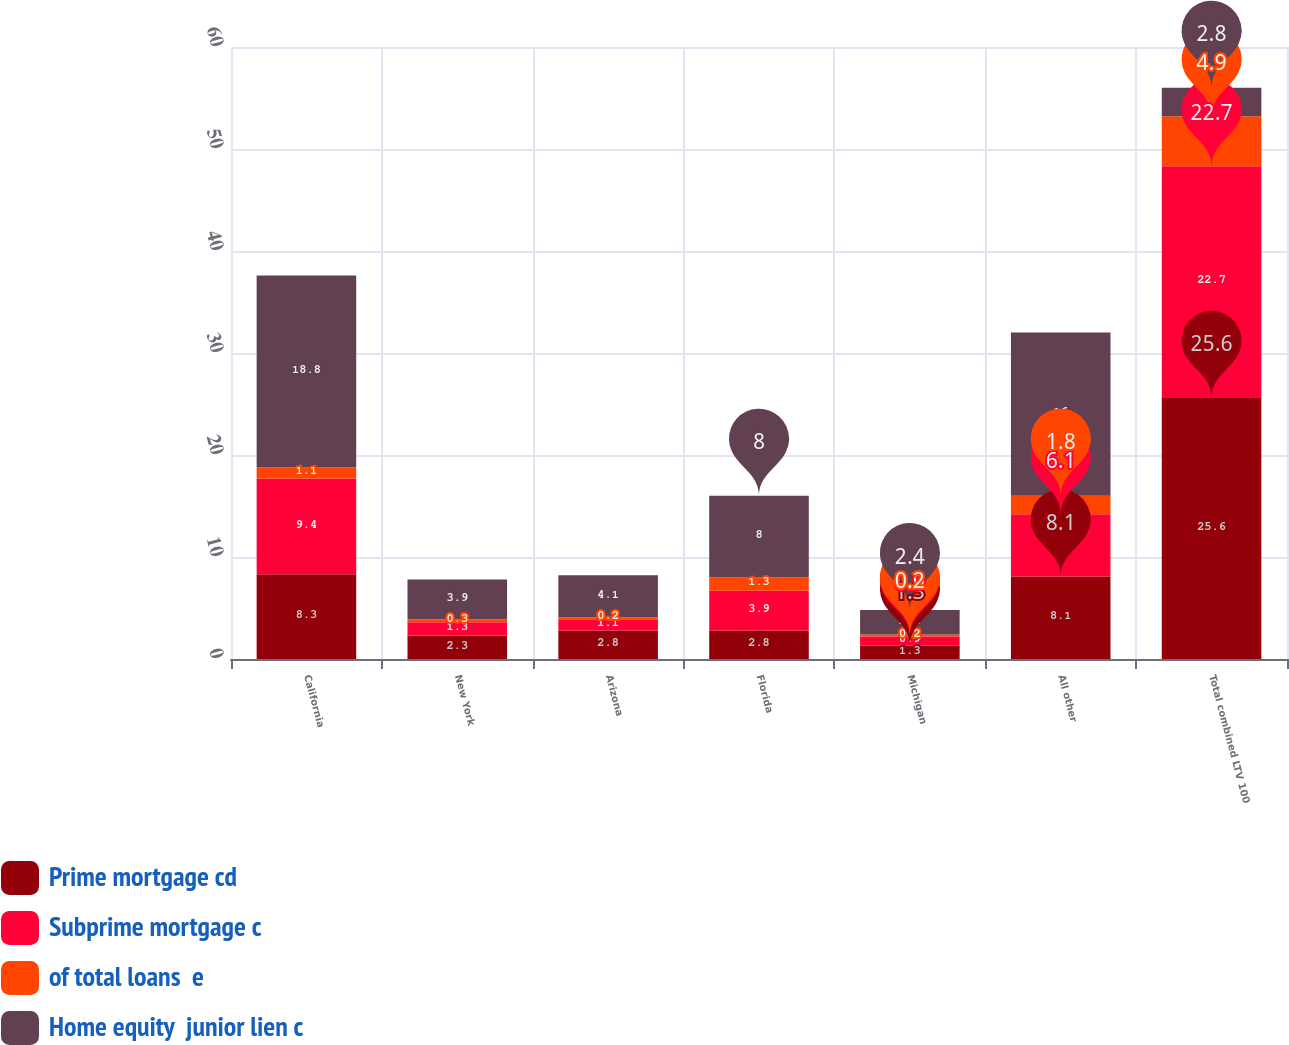Convert chart. <chart><loc_0><loc_0><loc_500><loc_500><stacked_bar_chart><ecel><fcel>California<fcel>New York<fcel>Arizona<fcel>Florida<fcel>Michigan<fcel>All other<fcel>Total combined LTV 100<nl><fcel>Prime mortgage cd<fcel>8.3<fcel>2.3<fcel>2.8<fcel>2.8<fcel>1.3<fcel>8.1<fcel>25.6<nl><fcel>Subprime mortgage c<fcel>9.4<fcel>1.3<fcel>1.1<fcel>3.9<fcel>0.9<fcel>6.1<fcel>22.7<nl><fcel>of total loans  e<fcel>1.1<fcel>0.3<fcel>0.2<fcel>1.3<fcel>0.2<fcel>1.8<fcel>4.9<nl><fcel>Home equity  junior lien c<fcel>18.8<fcel>3.9<fcel>4.1<fcel>8<fcel>2.4<fcel>16<fcel>2.8<nl></chart> 